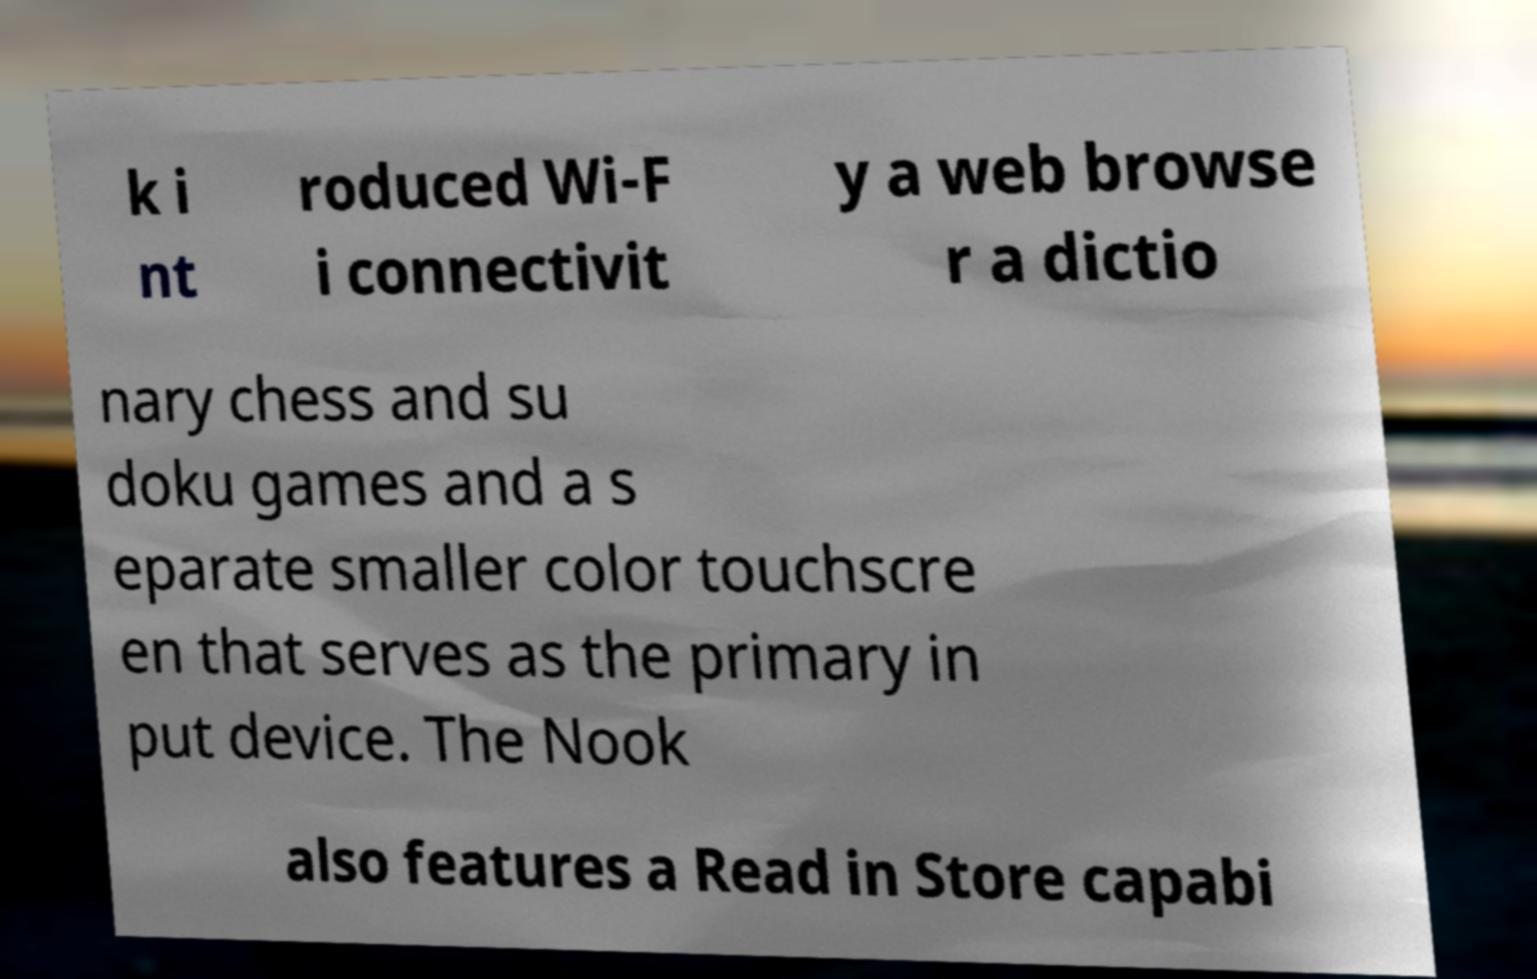For documentation purposes, I need the text within this image transcribed. Could you provide that? k i nt roduced Wi-F i connectivit y a web browse r a dictio nary chess and su doku games and a s eparate smaller color touchscre en that serves as the primary in put device. The Nook also features a Read in Store capabi 